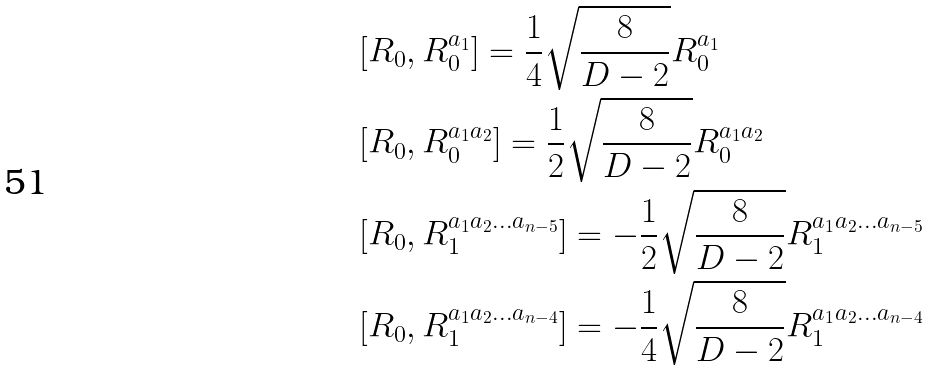<formula> <loc_0><loc_0><loc_500><loc_500>& [ R _ { 0 } , R _ { 0 } ^ { a _ { 1 } } ] = \frac { 1 } { 4 } \sqrt { \frac { 8 } { D - 2 } } R _ { 0 } ^ { a _ { 1 } } \\ & [ R _ { 0 } , R _ { 0 } ^ { a _ { 1 } a _ { 2 } } ] = \frac { 1 } { 2 } \sqrt { \frac { 8 } { D - 2 } } R _ { 0 } ^ { a _ { 1 } a _ { 2 } } \\ & [ R _ { 0 } , R _ { 1 } ^ { a _ { 1 } a _ { 2 } \dots a _ { n - 5 } } ] = - \frac { 1 } { 2 } \sqrt { \frac { 8 } { D - 2 } } R _ { 1 } ^ { a _ { 1 } a _ { 2 } \dots a _ { n - 5 } } \\ & [ R _ { 0 } , R _ { 1 } ^ { a _ { 1 } a _ { 2 } \dots a _ { n - 4 } } ] = - \frac { 1 } { 4 } \sqrt { \frac { 8 } { D - 2 } } R _ { 1 } ^ { a _ { 1 } a _ { 2 } \dots a _ { n - 4 } }</formula> 